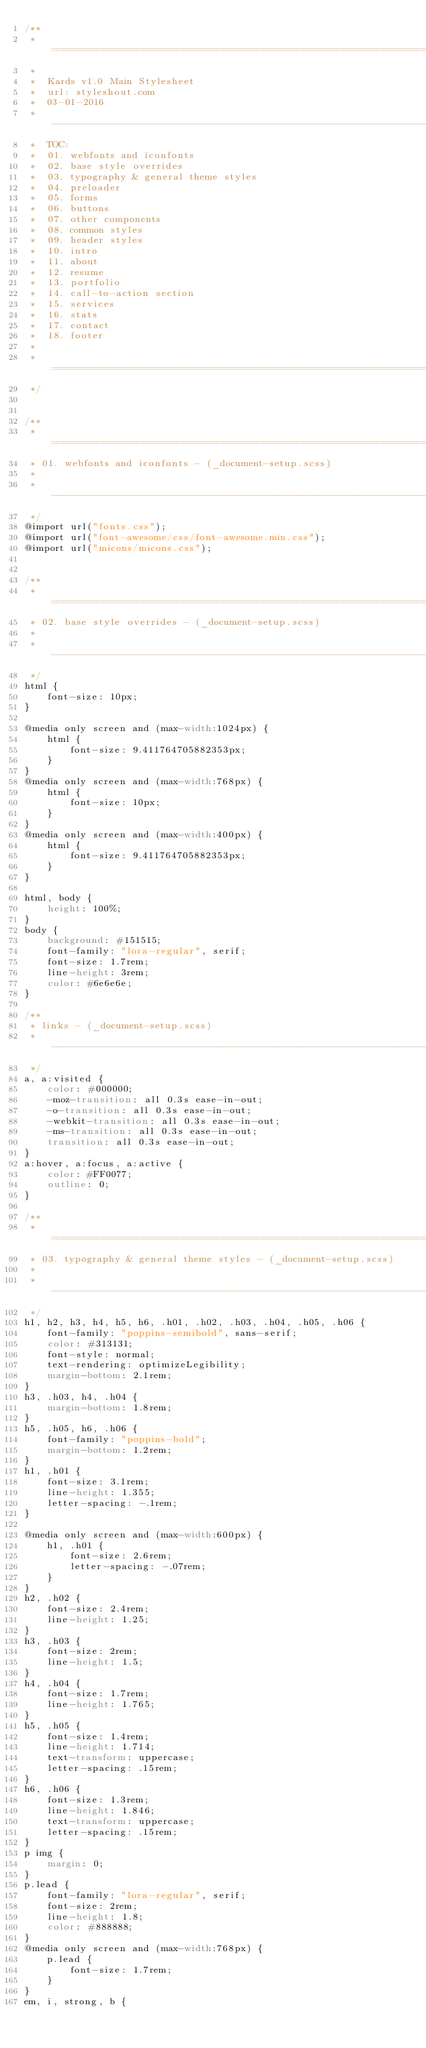Convert code to text. <code><loc_0><loc_0><loc_500><loc_500><_CSS_>/**
 * =================================================================== 
 *
 *  Kards v1.0 Main Stylesheet
 *  url: styleshout.com
 *  03-01-2016
 *  ------------------------------------------------------------------
 *  TOC:
 *  01. webfonts and iconfonts
 *  02. base style overrides
 *  03. typography & general theme styles
 *  04. preloader
 *  05. forms
 *  06. buttons 
 *  07. other components
 *  08. common styles
 *  09. header styles
 *  10. intro
 *  11. about
 *  12. resume
 *  13. portfolio
 *  14. call-to-action section
 *  15. services
 *  16. stats
 *  17. contact
 *  18. footer
 *
 * =================================================================== 
 */


/** 
 * ===================================================================
 * 01. webfonts and iconfonts - (_document-setup.scss)
 *
 * ------------------------------------------------------------------- 
 */
@import url("fonts.css");
@import url("font-awesome/css/font-awesome.min.css");
@import url("micons/micons.css");


/** 
 * ===================================================================
 * 02. base style overrides - (_document-setup.scss)
 *
 * ------------------------------------------------------------------- 
 */
html {
	font-size: 10px;
}

@media only screen and (max-width:1024px) {
	html {
		font-size: 9.411764705882353px;
	}
}
@media only screen and (max-width:768px) {
	html {
		font-size: 10px;
	}
}
@media only screen and (max-width:400px) {
	html {
		font-size: 9.411764705882353px;
	}
}

html, body {
	height: 100%;
}
body {
	background: #151515;
	font-family: "lora-regular", serif;
	font-size: 1.7rem;
	line-height: 3rem;
	color: #6e6e6e;
}

/**
 * links - (_document-setup.scss)
 * -------------------------------------------------------------------
 */
a, a:visited {
	color: #000000;
	-moz-transition: all 0.3s ease-in-out;
	-o-transition: all 0.3s ease-in-out;
	-webkit-transition: all 0.3s ease-in-out;
	-ms-transition: all 0.3s ease-in-out;
	transition: all 0.3s ease-in-out;
}
a:hover, a:focus, a:active {
	color: #FF0077;
	outline: 0;
}

/** 
 * ===================================================================
 * 03. typography & general theme styles - (_document-setup.scss)
 *
 * ------------------------------------------------------------------- 
 */
h1, h2, h3, h4, h5, h6, .h01, .h02, .h03, .h04, .h05, .h06 {
	font-family: "poppins-semibold", sans-serif;
	color: #313131;
	font-style: normal;
	text-rendering: optimizeLegibility;
	margin-bottom: 2.1rem;
}
h3, .h03, h4, .h04 {
	margin-bottom: 1.8rem;
}
h5, .h05, h6, .h06 {
	font-family: "poppins-bold";
	margin-bottom: 1.2rem;
}
h1, .h01 {
	font-size: 3.1rem;
	line-height: 1.355;
	letter-spacing: -.1rem;
}

@media only screen and (max-width:600px) {
	h1, .h01 {
		font-size: 2.6rem;
		letter-spacing: -.07rem;
	}
}
h2, .h02 {
	font-size: 2.4rem;
	line-height: 1.25;
}
h3, .h03 {
	font-size: 2rem;
	line-height: 1.5;
}
h4, .h04 {
	font-size: 1.7rem;
	line-height: 1.765;
}
h5, .h05 {
	font-size: 1.4rem;
	line-height: 1.714;
	text-transform: uppercase;
	letter-spacing: .15rem;
}
h6, .h06 {
	font-size: 1.3rem;
	line-height: 1.846;
	text-transform: uppercase;
	letter-spacing: .15rem;
}
p img {
	margin: 0;
}
p.lead {
	font-family: "lora-regular", serif;
	font-size: 2rem;
	line-height: 1.8;
	color: #888888;
}
@media only screen and (max-width:768px) {
	p.lead {
		font-size: 1.7rem;
	}
}
em, i, strong, b {</code> 